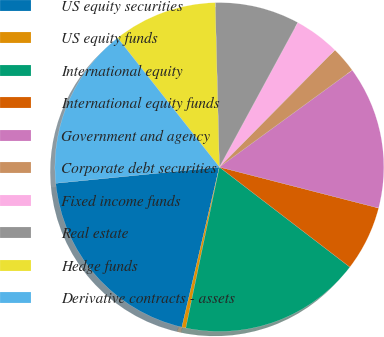<chart> <loc_0><loc_0><loc_500><loc_500><pie_chart><fcel>US equity securities<fcel>US equity funds<fcel>International equity<fcel>International equity funds<fcel>Government and agency<fcel>Corporate debt securities<fcel>Fixed income funds<fcel>Real estate<fcel>Hedge funds<fcel>Derivative contracts - assets<nl><fcel>19.77%<fcel>0.39%<fcel>17.86%<fcel>6.4%<fcel>14.04%<fcel>2.58%<fcel>4.49%<fcel>8.31%<fcel>10.22%<fcel>15.95%<nl></chart> 